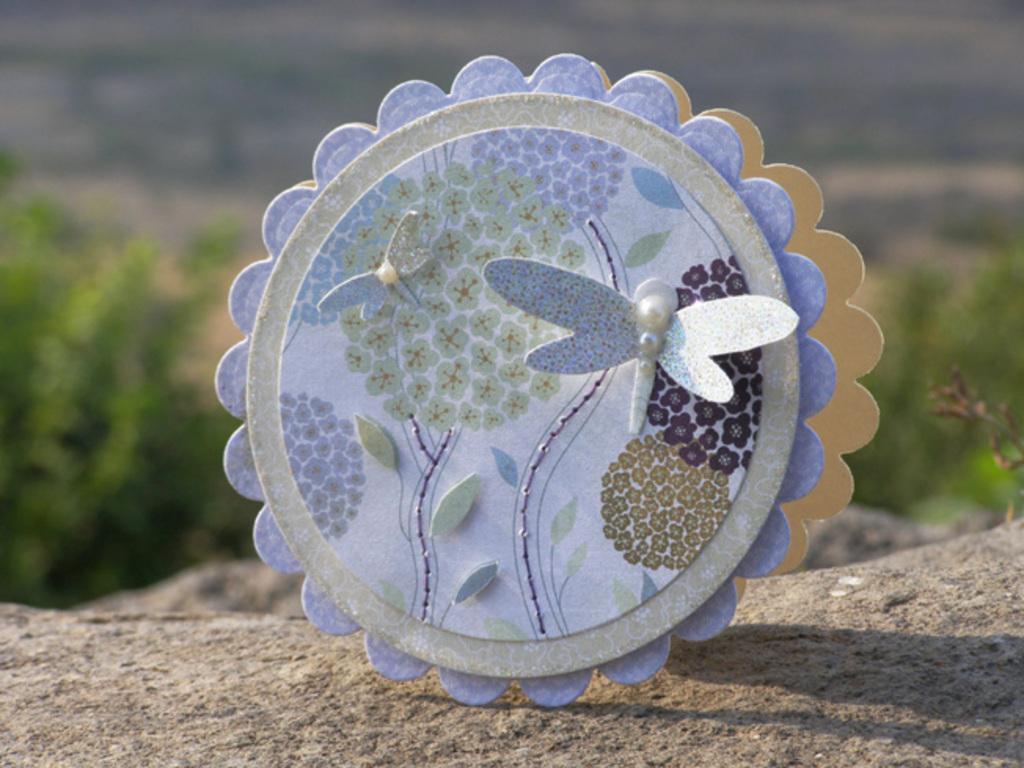Please provide a concise description of this image. In this image in the front there is a colourful object and the background is blurry. 